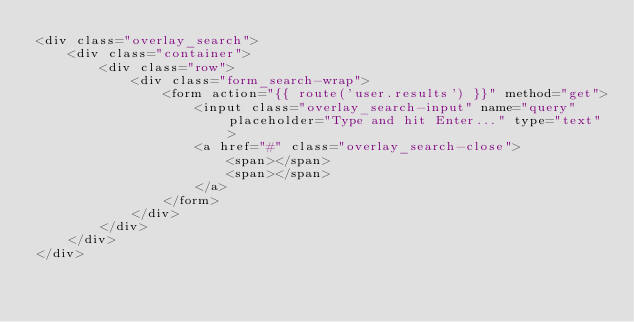Convert code to text. <code><loc_0><loc_0><loc_500><loc_500><_PHP_><div class="overlay_search">
    <div class="container">
        <div class="row">
            <div class="form_search-wrap">
                <form action="{{ route('user.results') }}" method="get">
                    <input class="overlay_search-input" name="query" placeholder="Type and hit Enter..." type="text">
                    <a href="#" class="overlay_search-close">
                        <span></span>
                        <span></span>
                    </a>
                </form>
            </div>
        </div>
    </div>
</div></code> 